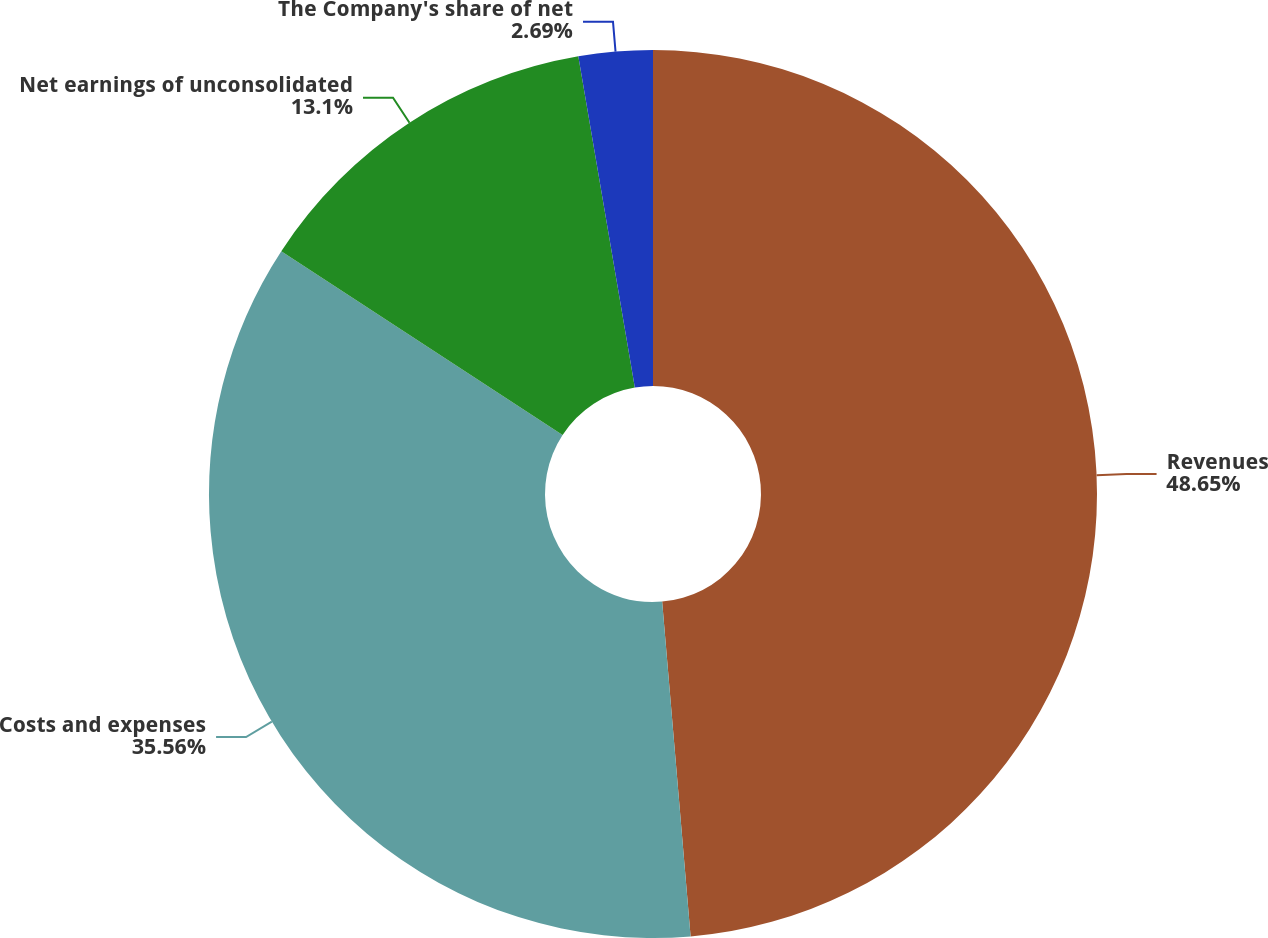<chart> <loc_0><loc_0><loc_500><loc_500><pie_chart><fcel>Revenues<fcel>Costs and expenses<fcel>Net earnings of unconsolidated<fcel>The Company's share of net<nl><fcel>48.65%<fcel>35.56%<fcel>13.1%<fcel>2.69%<nl></chart> 